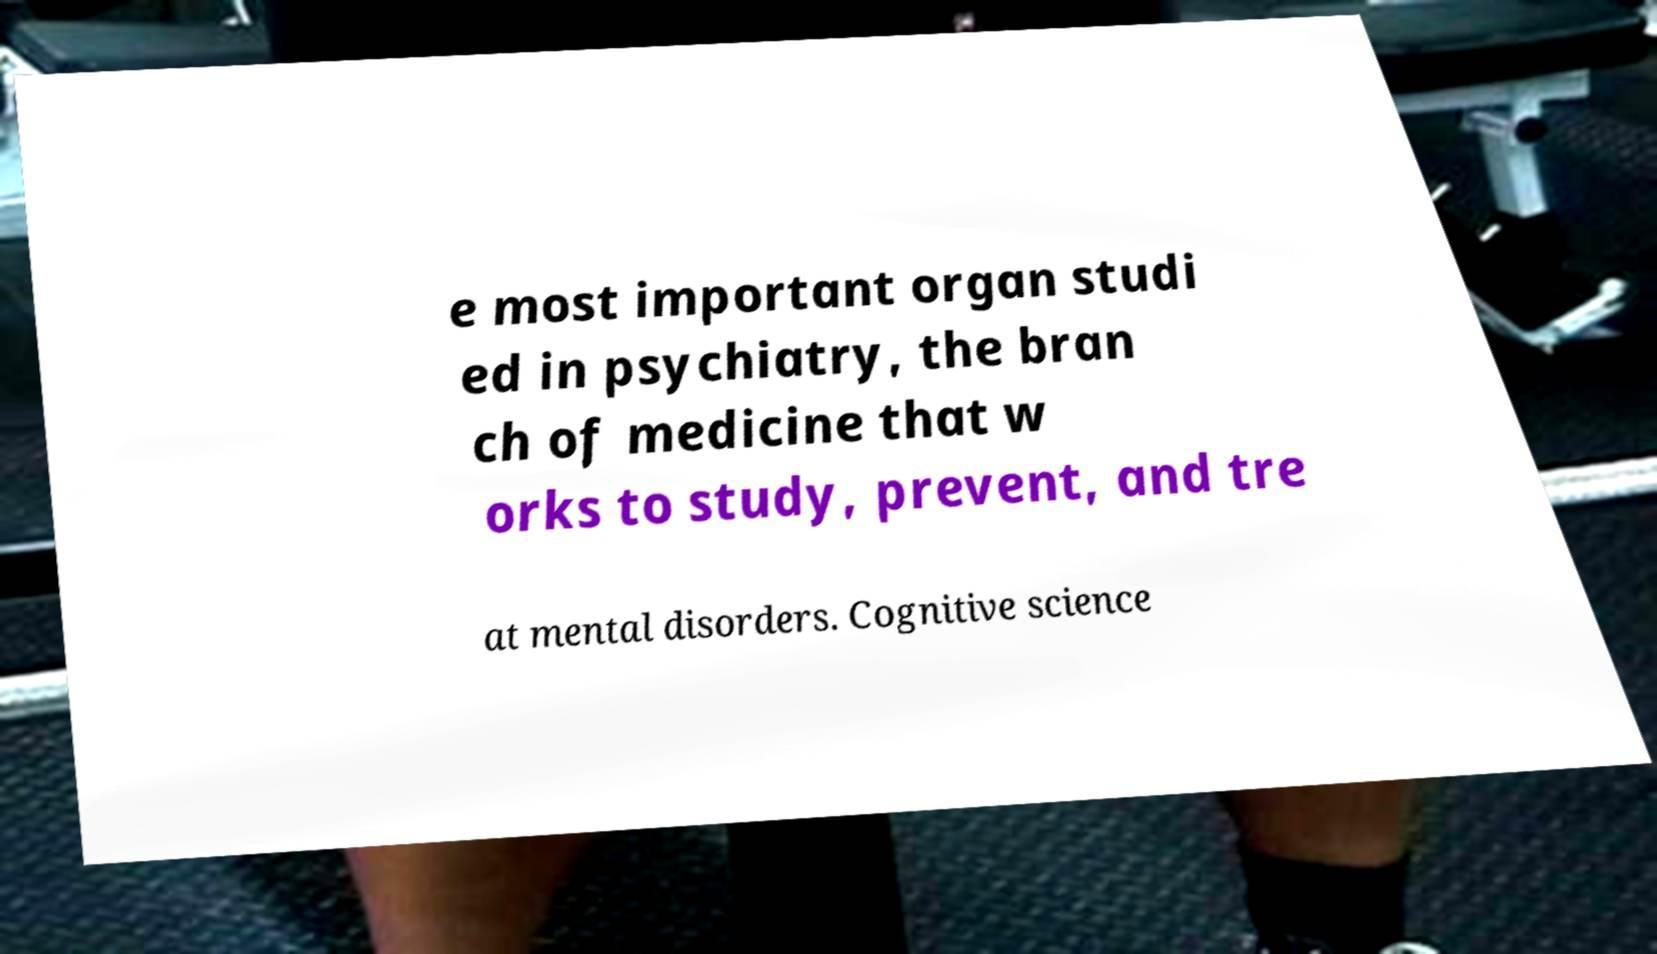Could you extract and type out the text from this image? e most important organ studi ed in psychiatry, the bran ch of medicine that w orks to study, prevent, and tre at mental disorders. Cognitive science 